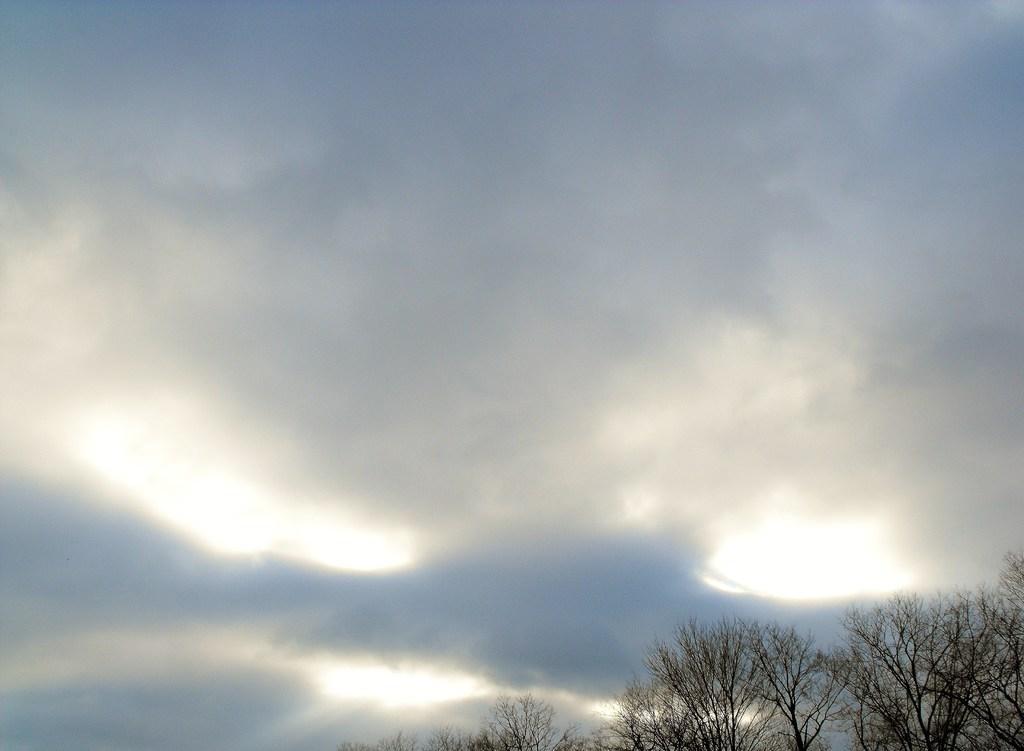How would you summarize this image in a sentence or two? In this image we can see sky, clouds and trees. 